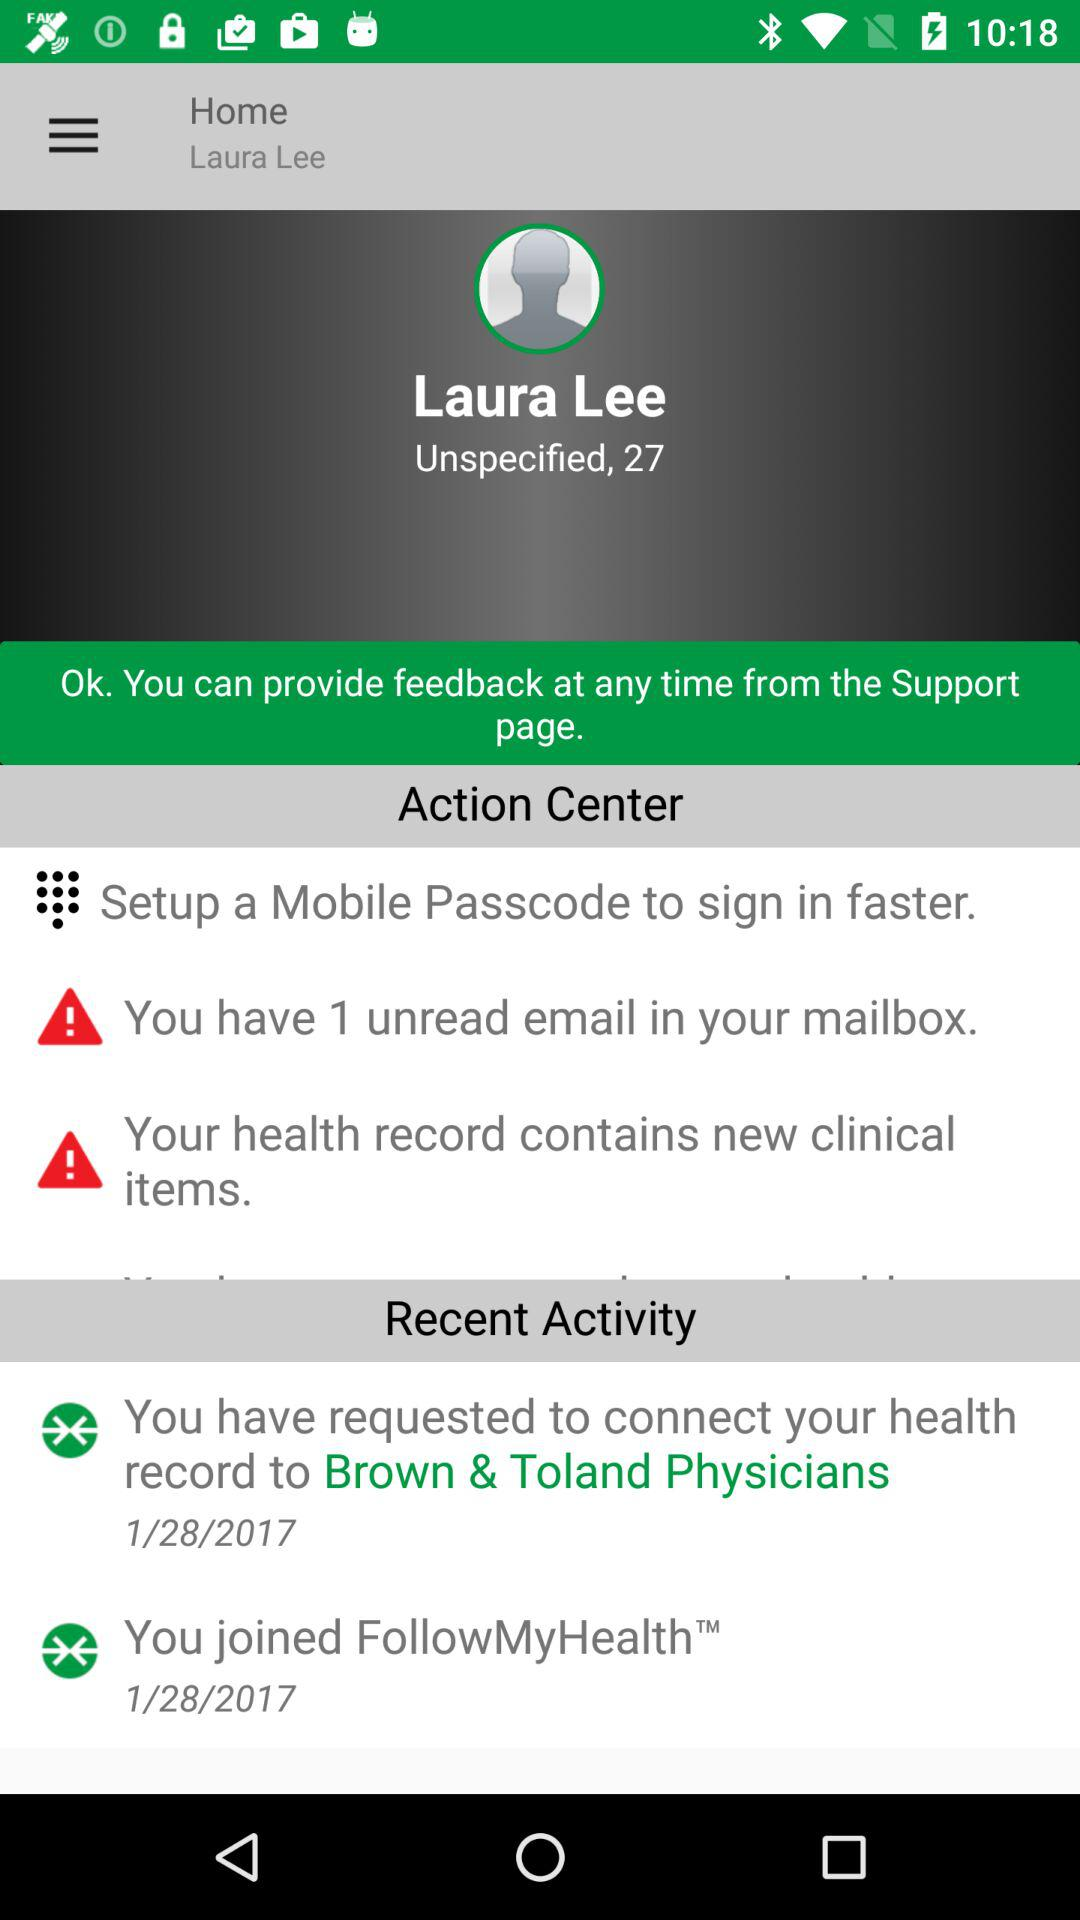What is the age of the user? The user is 27 years old. 